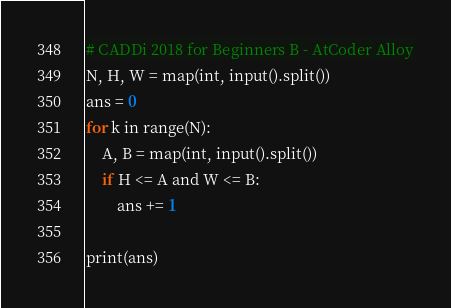Convert code to text. <code><loc_0><loc_0><loc_500><loc_500><_Python_># CADDi 2018 for Beginners B - AtCoder Alloy
N, H, W = map(int, input().split())
ans = 0
for k in range(N):
    A, B = map(int, input().split())
    if H <= A and W <= B:
        ans += 1

print(ans)</code> 